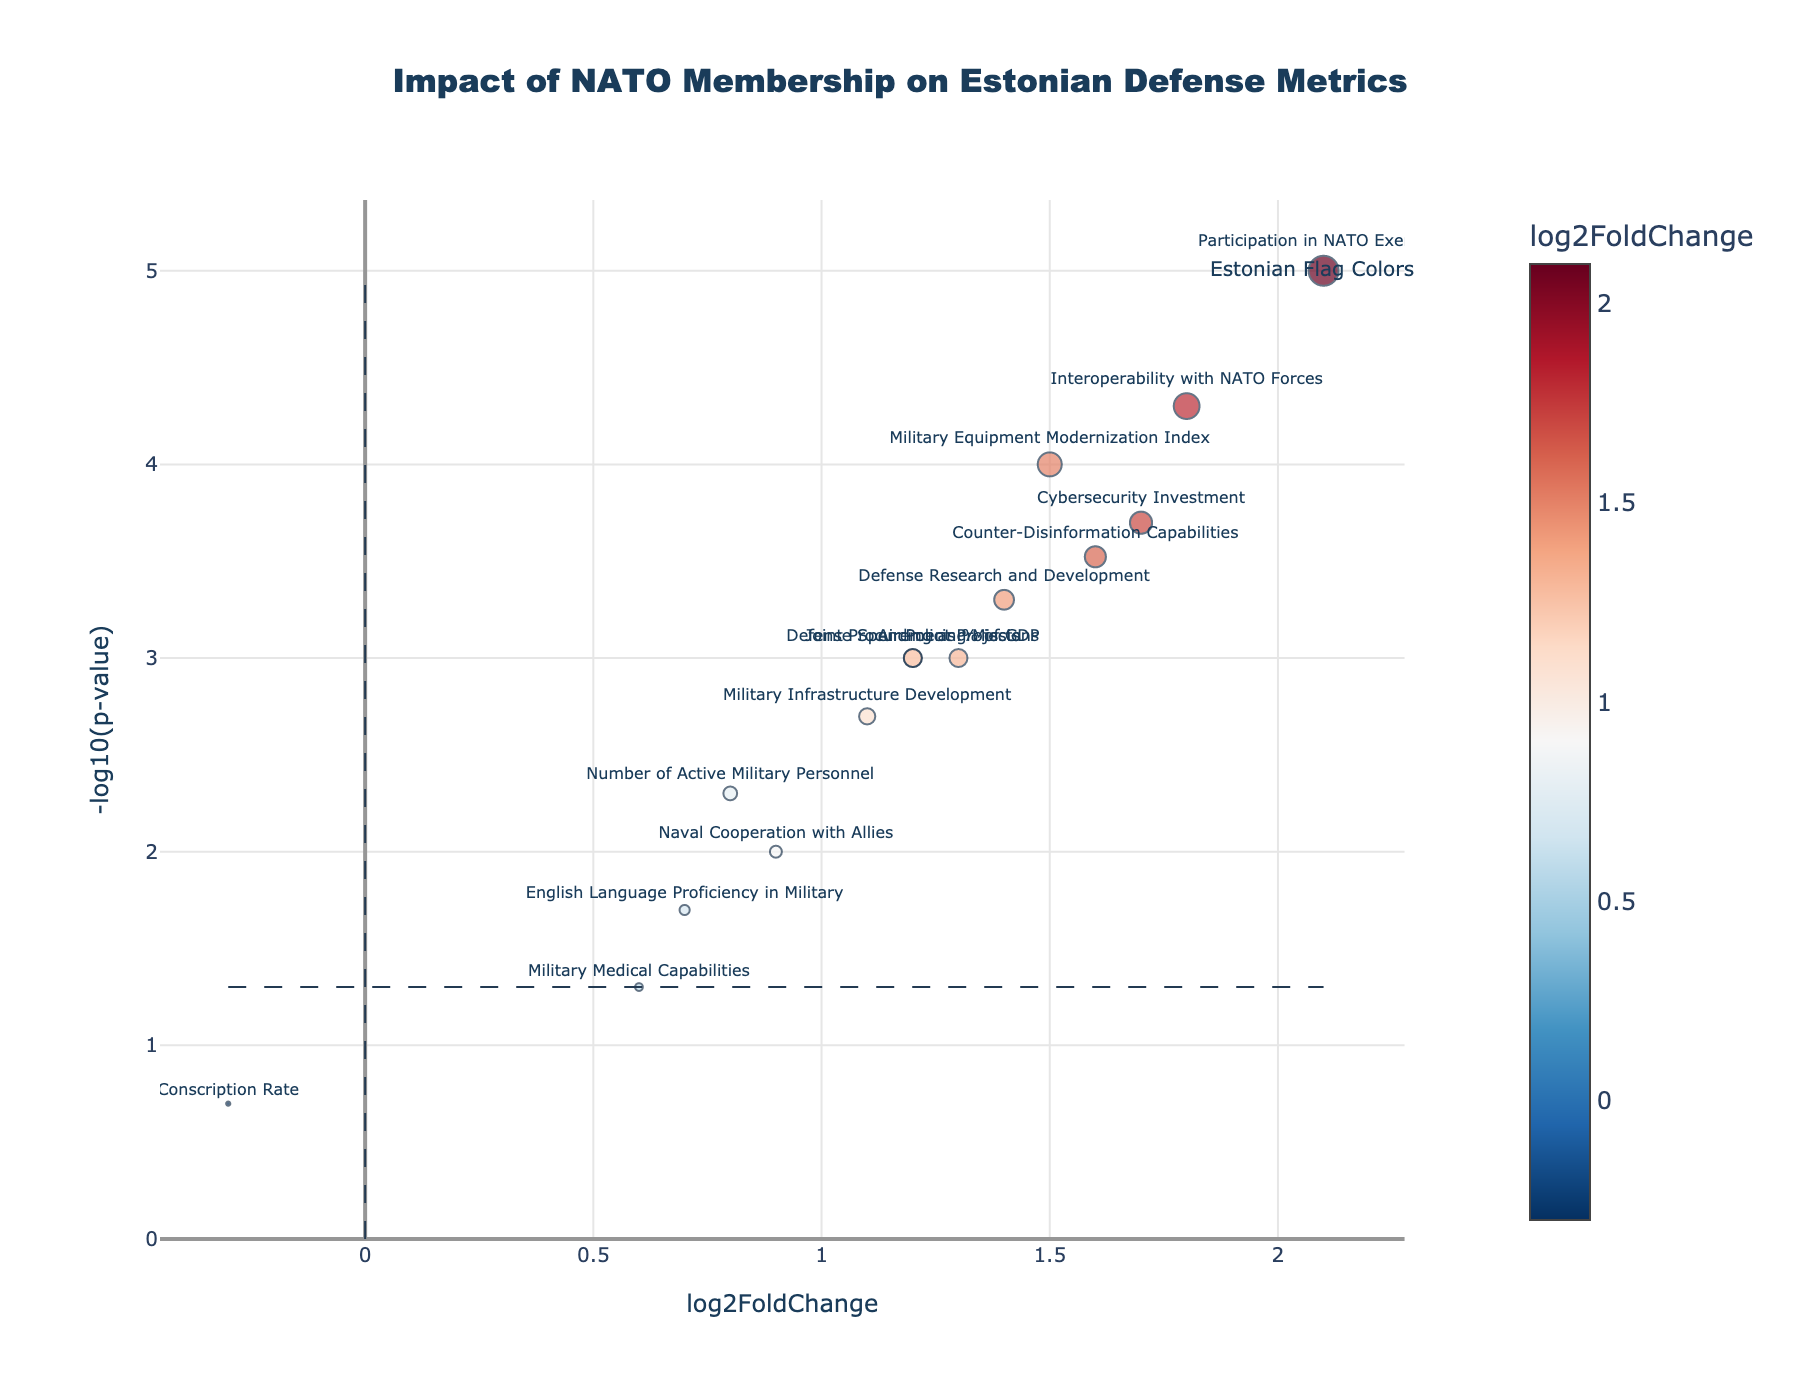Which metric has the highest log2FoldChange value? Identify the data point furthest to the right on the x-axis.
Answer: Participation in NATO Exercises What does the y-axis represent in this plot? Refer to the axis label on the figure. The y-axis is labeled "-log10(p-value)".
Answer: -log10(p-value) Which data point is associated with the highest -log10(p-value)? Find the data point located at the highest position on the y-axis.
Answer: Participation in NATO Exercises How does the "Conscription Rate" compare to other metrics in terms of log2FoldChange? Look for the "Conscription Rate" data point on the x-axis. It is the only point with a negative log2FoldChange, indicating it decreased while others increased.
Answer: It has a negative log2FoldChange Which metrics have a p-value less than 0.05? Identify points above the horizontal dashed line (y = -log10(0.05)) on the plot.
Answer: Defense Spending as % of GDP, Number of Active Military Personnel, Military Equipment Modernization Index, Participation in NATO Exercises, Cybersecurity Investment, Air Policing Missions, Naval Cooperation with Allies, Military Infrastructure Development, Defense Research and Development, Interoperability with NATO Forces, Counter-Disinformation Capabilities, Joint Procurement Projects What does the color of the markers represent in this figure? Examine the color bar legend next to the plot. It indicates that the color represents the log2FoldChange value.
Answer: log2FoldChange Which data point related to cooperation with allies has a relatively high log2FoldChange but a higher p-value than others? Look at the labels for "Naval Cooperation with Allies" and compare its position on the y-axis and x-axis. It has lower log2FoldChange and higher p-value compared to many other metrics.
Answer: Naval Cooperation with Allies On average, do cybersecurity investments show a higher log2FoldChange than military medical capabilities? Identify the "Cybersecurity Investment" and "Military Medical Capabilities" markers and compare their x-axis positions. The former is farther to the right.
Answer: Yes What is the significance threshold for p-values indicated in the plot? Refer to the horizontal dashed line and its corresponding y-value (-log10(0.05)) next to it.
Answer: 0.05 Which metric indicates the most substantial improvement in interoperation with NATO forces? Identify the marker for "Interoperability with NATO Forces" and check its x-axis and y-axis positions, both being high.
Answer: Interoperability with NATO Forces 